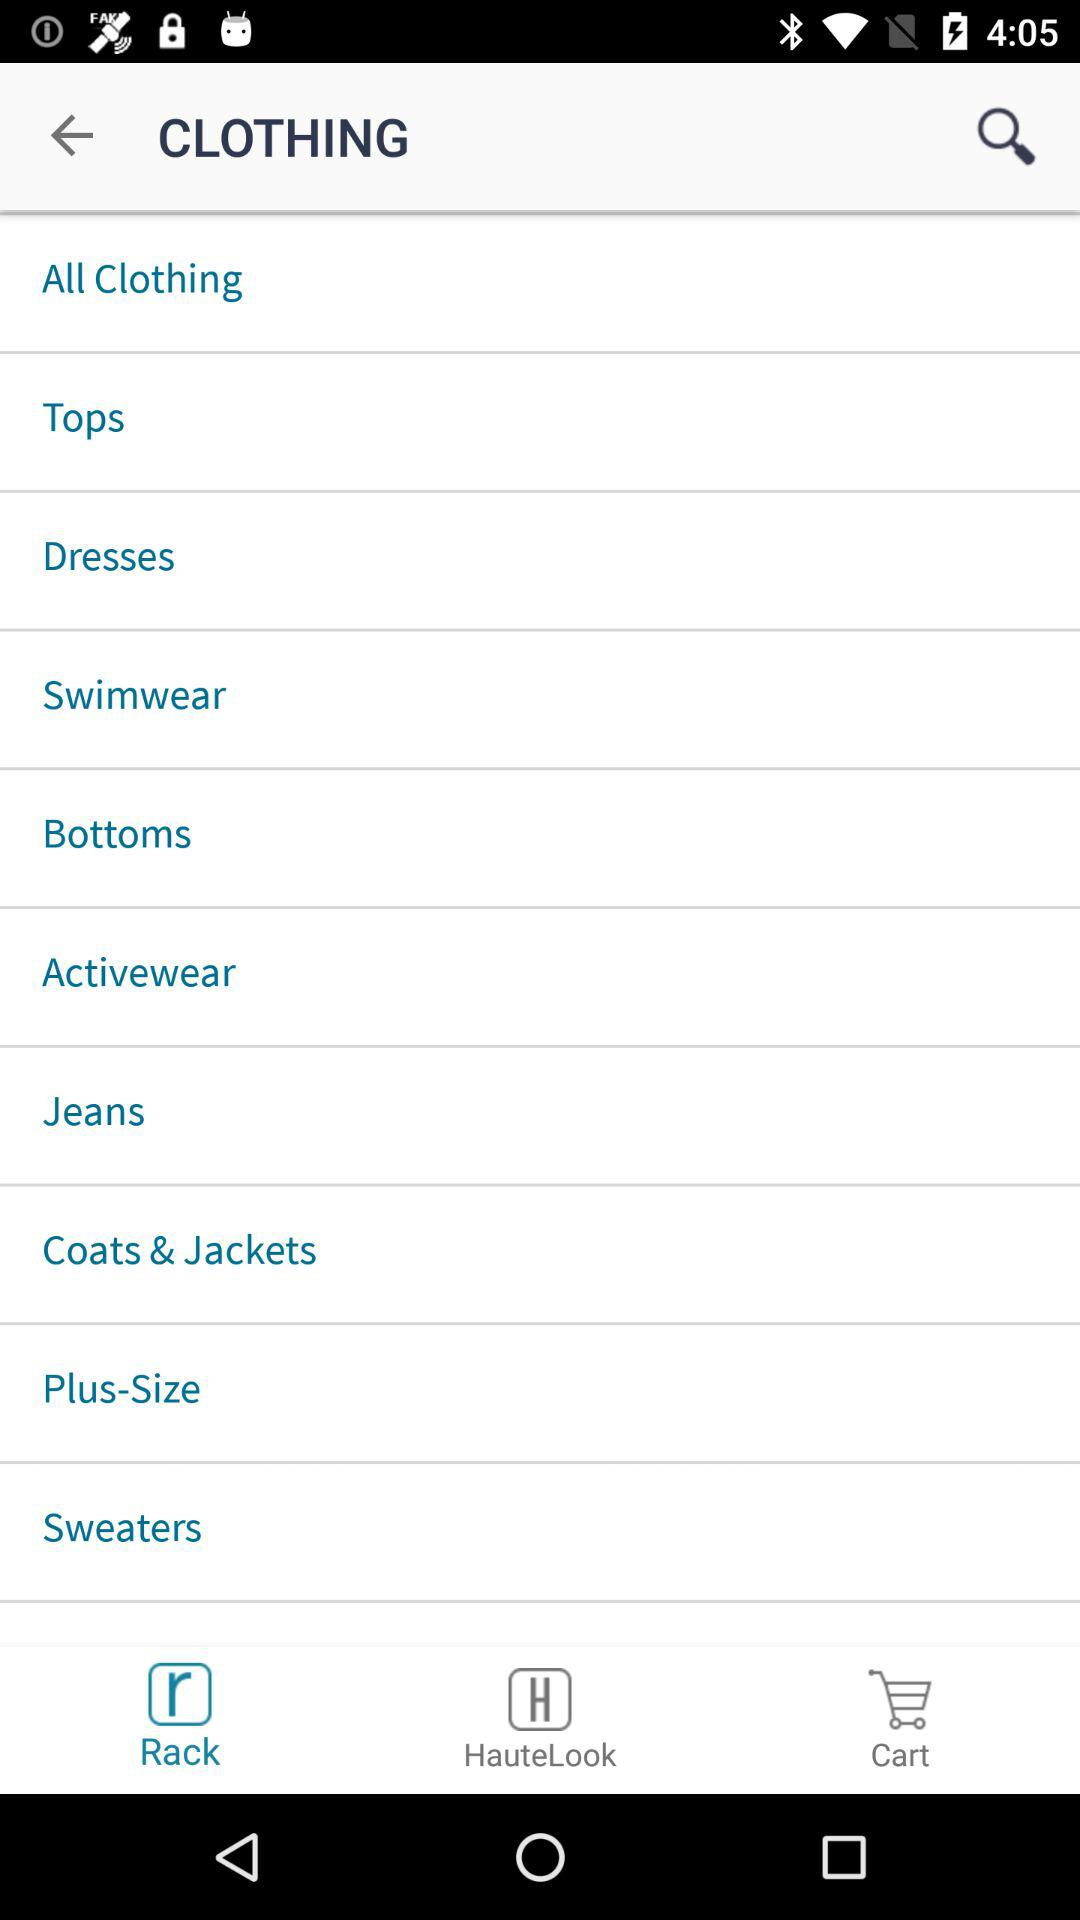Which tab is currently selected? The tab that is currently selected is "Rack". 